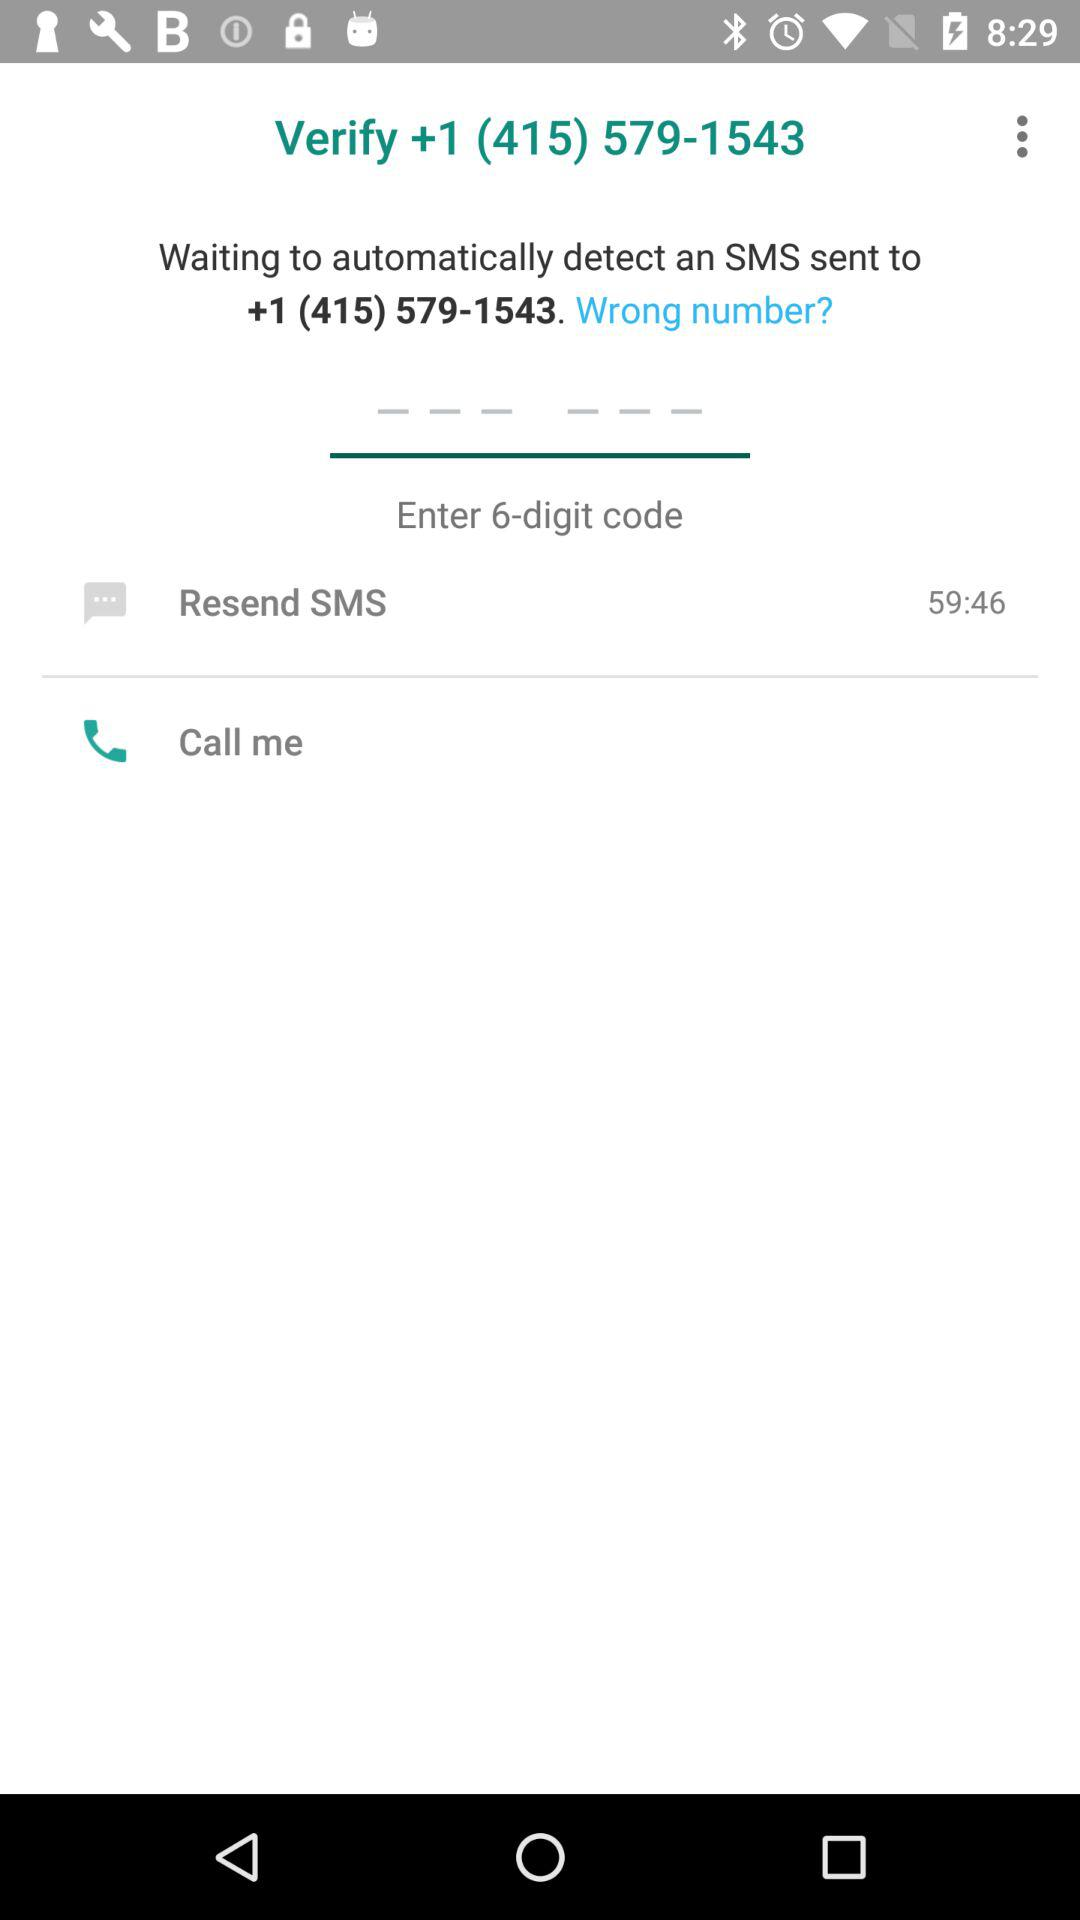After how much time will the SMS be resent? The SMS will be resent after 59 minutes and 46 seconds. 